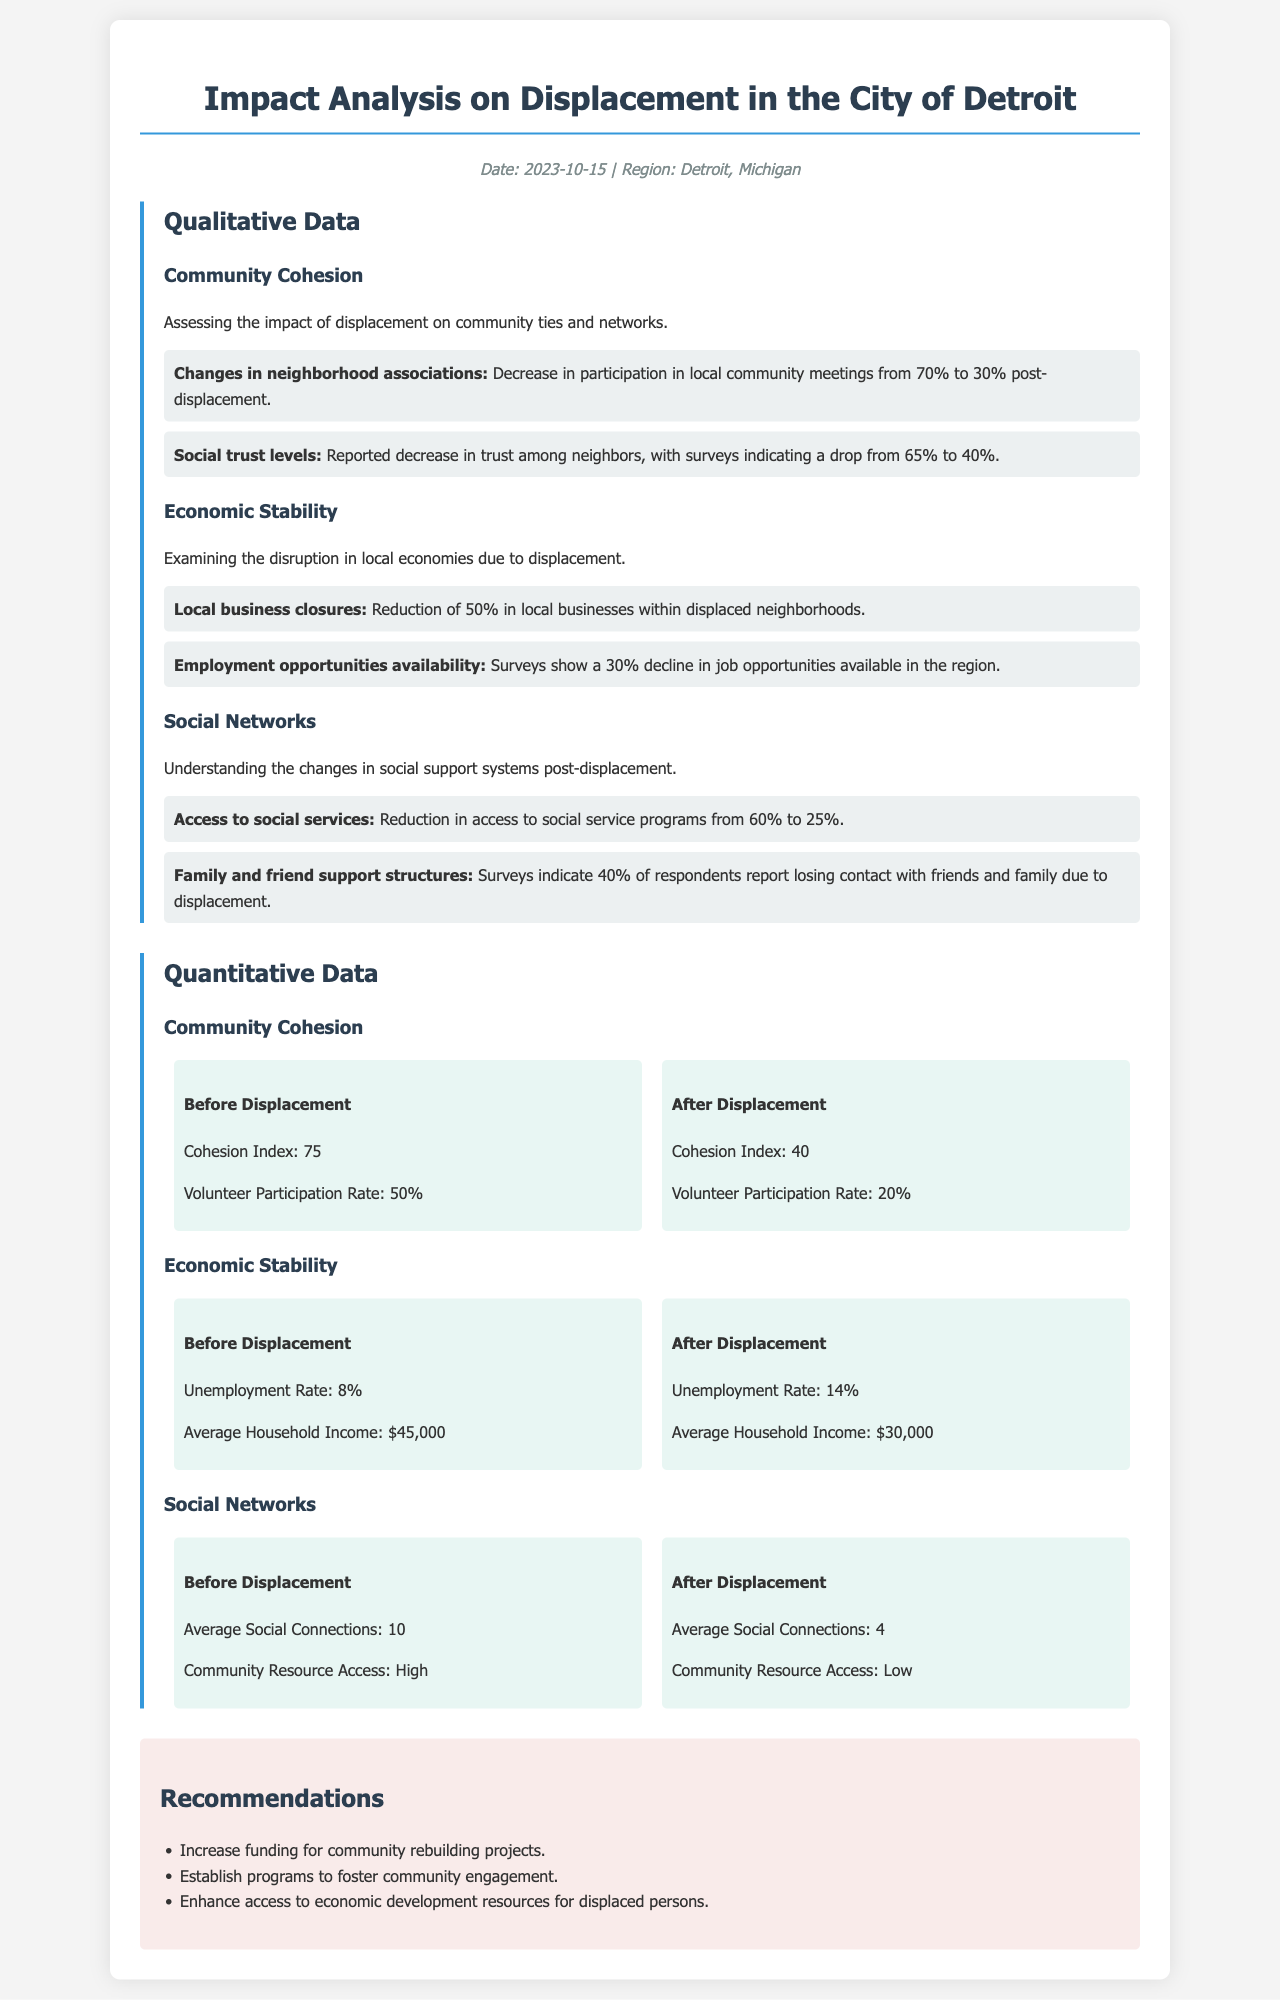What is the date of the report? The date of the report is mentioned at the top of the document, stating the specific date when the analysis was conducted.
Answer: 2023-10-15 What was the unemployment rate before displacement? The unemployment rate before displacement is provided in the quantitative data section, detailing economic stability metrics.
Answer: 8% What was the Cohesion Index after displacement? The Cohesion Index after displacement is a part of the statistical metrics reflecting community cohesion in the region.
Answer: 40 What percentage of local businesses closed due to displacement? The document specifies the percentage of local business closures within displaced neighborhoods as qualitative data related to economic stability.
Answer: 50% How much did access to social services decrease? This is derived from qualitative indicators showing the reduction in access to social service programs before and after displacement.
Answer: From 60% to 25% What is the average social connections after displacement? This information is detailed in the quantitative section regarding changes in social networks in the community following displacement.
Answer: 4 What recommendation is provided for community engagement? The recommendations section suggests specific actions to improve community cohesion and support for displaced individuals.
Answer: Establish programs to foster community engagement What was the average household income after displacement? The average household income is analyzed before and after displacement within the economic stability section of the document.
Answer: $30,000 What is the reported decline in job opportunities? The qualitative indicators outline the situation regarding employment opportunities available in the region after displacement.
Answer: 30% decline 